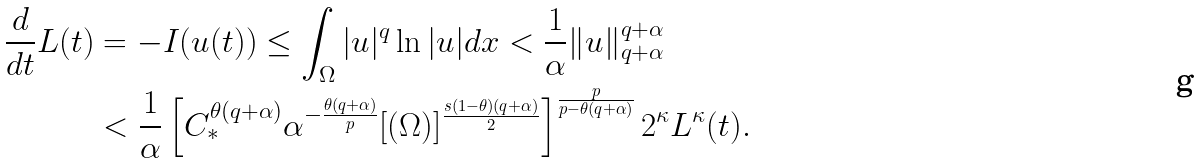Convert formula to latex. <formula><loc_0><loc_0><loc_500><loc_500>\frac { d } { d t } L ( t ) & = - I ( u ( t ) ) \leq \int _ { \Omega } | u | ^ { q } \ln | u | d x < \frac { 1 } { \alpha } \| u \| _ { q + \alpha } ^ { q + \alpha } \\ & < \frac { 1 } { \alpha } \left [ C _ { * } ^ { \theta ( q + \alpha ) } \alpha ^ { - \frac { \theta ( q + \alpha ) } { p } } [ ( \Omega ) ] ^ { \frac { s ( 1 - \theta ) ( q + \alpha ) } { 2 } } \right ] ^ { \frac { p } { p - \theta ( q + \alpha ) } } 2 ^ { \kappa } L ^ { \kappa } ( t ) .</formula> 